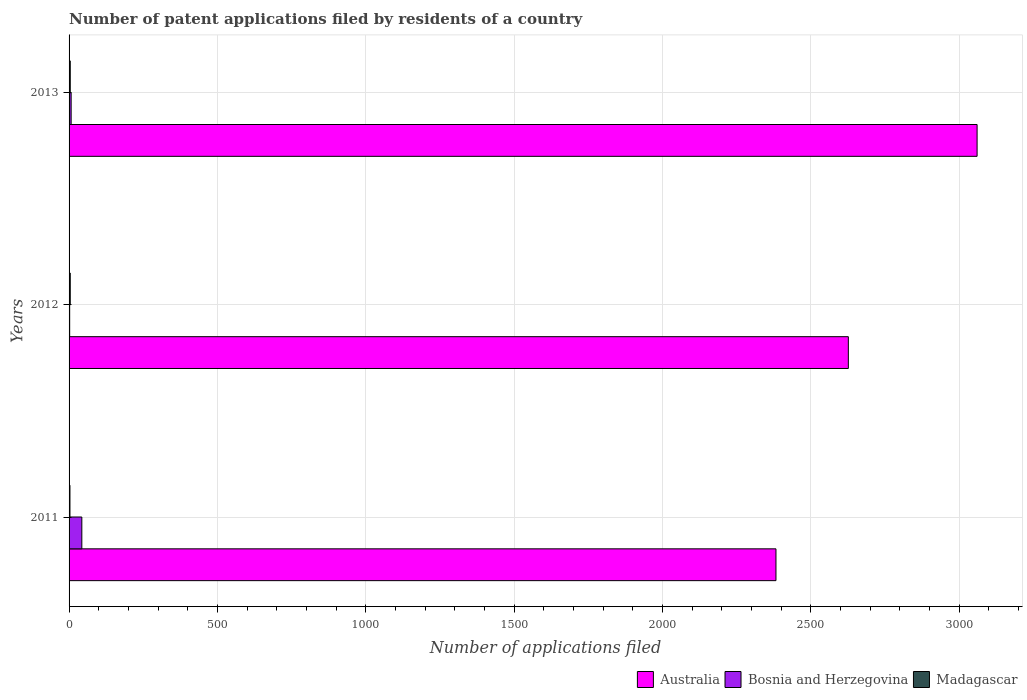How many different coloured bars are there?
Your response must be concise. 3. How many bars are there on the 2nd tick from the bottom?
Offer a terse response. 3. In how many cases, is the number of bars for a given year not equal to the number of legend labels?
Ensure brevity in your answer.  0. In which year was the number of applications filed in Bosnia and Herzegovina maximum?
Give a very brief answer. 2011. What is the total number of applications filed in Australia in the graph?
Your answer should be very brief. 8071. What is the difference between the number of applications filed in Madagascar in 2011 and that in 2012?
Your answer should be very brief. -1. What is the difference between the number of applications filed in Bosnia and Herzegovina in 2013 and the number of applications filed in Madagascar in 2012?
Ensure brevity in your answer.  3. What is the average number of applications filed in Madagascar per year?
Offer a terse response. 3.67. In the year 2012, what is the difference between the number of applications filed in Bosnia and Herzegovina and number of applications filed in Australia?
Your answer should be compact. -2625. In how many years, is the number of applications filed in Bosnia and Herzegovina greater than 2600 ?
Provide a short and direct response. 0. Is the difference between the number of applications filed in Bosnia and Herzegovina in 2011 and 2013 greater than the difference between the number of applications filed in Australia in 2011 and 2013?
Make the answer very short. Yes. What is the difference between the highest and the second highest number of applications filed in Bosnia and Herzegovina?
Your response must be concise. 36. What is the difference between the highest and the lowest number of applications filed in Australia?
Offer a terse response. 678. What does the 2nd bar from the top in 2011 represents?
Give a very brief answer. Bosnia and Herzegovina. What does the 2nd bar from the bottom in 2012 represents?
Provide a succinct answer. Bosnia and Herzegovina. How many bars are there?
Give a very brief answer. 9. Are all the bars in the graph horizontal?
Your answer should be compact. Yes. How many years are there in the graph?
Provide a short and direct response. 3. Does the graph contain any zero values?
Your response must be concise. No. What is the title of the graph?
Offer a terse response. Number of patent applications filed by residents of a country. What is the label or title of the X-axis?
Give a very brief answer. Number of applications filed. What is the Number of applications filed in Australia in 2011?
Make the answer very short. 2383. What is the Number of applications filed in Madagascar in 2011?
Ensure brevity in your answer.  3. What is the Number of applications filed of Australia in 2012?
Provide a short and direct response. 2627. What is the Number of applications filed of Bosnia and Herzegovina in 2012?
Provide a succinct answer. 2. What is the Number of applications filed in Madagascar in 2012?
Provide a short and direct response. 4. What is the Number of applications filed of Australia in 2013?
Offer a very short reply. 3061. What is the Number of applications filed in Madagascar in 2013?
Your answer should be compact. 4. Across all years, what is the maximum Number of applications filed of Australia?
Keep it short and to the point. 3061. Across all years, what is the maximum Number of applications filed of Madagascar?
Provide a succinct answer. 4. Across all years, what is the minimum Number of applications filed in Australia?
Keep it short and to the point. 2383. Across all years, what is the minimum Number of applications filed of Bosnia and Herzegovina?
Your answer should be very brief. 2. What is the total Number of applications filed in Australia in the graph?
Give a very brief answer. 8071. What is the difference between the Number of applications filed in Australia in 2011 and that in 2012?
Give a very brief answer. -244. What is the difference between the Number of applications filed in Bosnia and Herzegovina in 2011 and that in 2012?
Your response must be concise. 41. What is the difference between the Number of applications filed of Australia in 2011 and that in 2013?
Provide a short and direct response. -678. What is the difference between the Number of applications filed in Bosnia and Herzegovina in 2011 and that in 2013?
Give a very brief answer. 36. What is the difference between the Number of applications filed of Australia in 2012 and that in 2013?
Keep it short and to the point. -434. What is the difference between the Number of applications filed of Bosnia and Herzegovina in 2012 and that in 2013?
Provide a succinct answer. -5. What is the difference between the Number of applications filed in Madagascar in 2012 and that in 2013?
Offer a very short reply. 0. What is the difference between the Number of applications filed of Australia in 2011 and the Number of applications filed of Bosnia and Herzegovina in 2012?
Ensure brevity in your answer.  2381. What is the difference between the Number of applications filed in Australia in 2011 and the Number of applications filed in Madagascar in 2012?
Your answer should be very brief. 2379. What is the difference between the Number of applications filed in Bosnia and Herzegovina in 2011 and the Number of applications filed in Madagascar in 2012?
Make the answer very short. 39. What is the difference between the Number of applications filed of Australia in 2011 and the Number of applications filed of Bosnia and Herzegovina in 2013?
Keep it short and to the point. 2376. What is the difference between the Number of applications filed in Australia in 2011 and the Number of applications filed in Madagascar in 2013?
Give a very brief answer. 2379. What is the difference between the Number of applications filed in Bosnia and Herzegovina in 2011 and the Number of applications filed in Madagascar in 2013?
Ensure brevity in your answer.  39. What is the difference between the Number of applications filed in Australia in 2012 and the Number of applications filed in Bosnia and Herzegovina in 2013?
Give a very brief answer. 2620. What is the difference between the Number of applications filed of Australia in 2012 and the Number of applications filed of Madagascar in 2013?
Your answer should be compact. 2623. What is the average Number of applications filed in Australia per year?
Provide a succinct answer. 2690.33. What is the average Number of applications filed of Bosnia and Herzegovina per year?
Offer a very short reply. 17.33. What is the average Number of applications filed of Madagascar per year?
Offer a very short reply. 3.67. In the year 2011, what is the difference between the Number of applications filed of Australia and Number of applications filed of Bosnia and Herzegovina?
Provide a succinct answer. 2340. In the year 2011, what is the difference between the Number of applications filed of Australia and Number of applications filed of Madagascar?
Provide a succinct answer. 2380. In the year 2011, what is the difference between the Number of applications filed of Bosnia and Herzegovina and Number of applications filed of Madagascar?
Give a very brief answer. 40. In the year 2012, what is the difference between the Number of applications filed in Australia and Number of applications filed in Bosnia and Herzegovina?
Provide a succinct answer. 2625. In the year 2012, what is the difference between the Number of applications filed in Australia and Number of applications filed in Madagascar?
Your answer should be compact. 2623. In the year 2012, what is the difference between the Number of applications filed in Bosnia and Herzegovina and Number of applications filed in Madagascar?
Make the answer very short. -2. In the year 2013, what is the difference between the Number of applications filed in Australia and Number of applications filed in Bosnia and Herzegovina?
Your answer should be very brief. 3054. In the year 2013, what is the difference between the Number of applications filed of Australia and Number of applications filed of Madagascar?
Give a very brief answer. 3057. In the year 2013, what is the difference between the Number of applications filed of Bosnia and Herzegovina and Number of applications filed of Madagascar?
Keep it short and to the point. 3. What is the ratio of the Number of applications filed of Australia in 2011 to that in 2012?
Ensure brevity in your answer.  0.91. What is the ratio of the Number of applications filed in Madagascar in 2011 to that in 2012?
Provide a succinct answer. 0.75. What is the ratio of the Number of applications filed of Australia in 2011 to that in 2013?
Offer a very short reply. 0.78. What is the ratio of the Number of applications filed in Bosnia and Herzegovina in 2011 to that in 2013?
Your answer should be compact. 6.14. What is the ratio of the Number of applications filed in Madagascar in 2011 to that in 2013?
Give a very brief answer. 0.75. What is the ratio of the Number of applications filed of Australia in 2012 to that in 2013?
Provide a succinct answer. 0.86. What is the ratio of the Number of applications filed of Bosnia and Herzegovina in 2012 to that in 2013?
Offer a terse response. 0.29. What is the difference between the highest and the second highest Number of applications filed in Australia?
Give a very brief answer. 434. What is the difference between the highest and the second highest Number of applications filed of Madagascar?
Ensure brevity in your answer.  0. What is the difference between the highest and the lowest Number of applications filed of Australia?
Keep it short and to the point. 678. What is the difference between the highest and the lowest Number of applications filed of Bosnia and Herzegovina?
Make the answer very short. 41. 